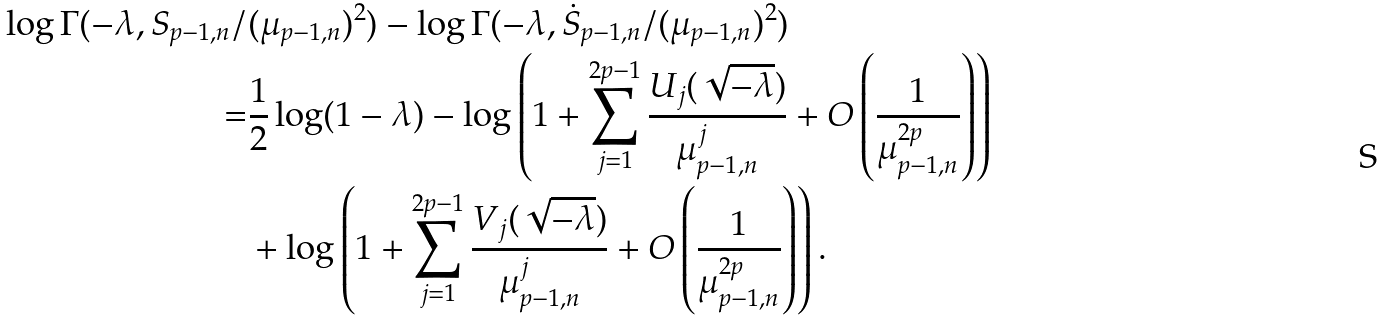Convert formula to latex. <formula><loc_0><loc_0><loc_500><loc_500>\log \Gamma ( - \lambda , S _ { p - 1 , n } / & ( \mu _ { p - 1 , n } ) ^ { 2 } ) - \log \Gamma ( - \lambda , \dot { S } _ { p - 1 , n } / ( \mu _ { p - 1 , n } ) ^ { 2 } ) \\ = & \frac { 1 } { 2 } \log ( 1 - \lambda ) - \log \left ( 1 + \sum _ { j = 1 } ^ { 2 p - 1 } \frac { U _ { j } ( \sqrt { - \lambda } ) } { \mu _ { p - 1 , n } ^ { j } } + O \left ( \frac { 1 } { \mu _ { p - 1 , n } ^ { 2 p } } \right ) \right ) \\ & + \log \left ( 1 + \sum _ { j = 1 } ^ { 2 p - 1 } \frac { V _ { j } ( \sqrt { - \lambda } ) } { \mu _ { p - 1 , n } ^ { j } } + O \left ( \frac { 1 } { \mu _ { p - 1 , n } ^ { 2 p } } \right ) \right ) .</formula> 